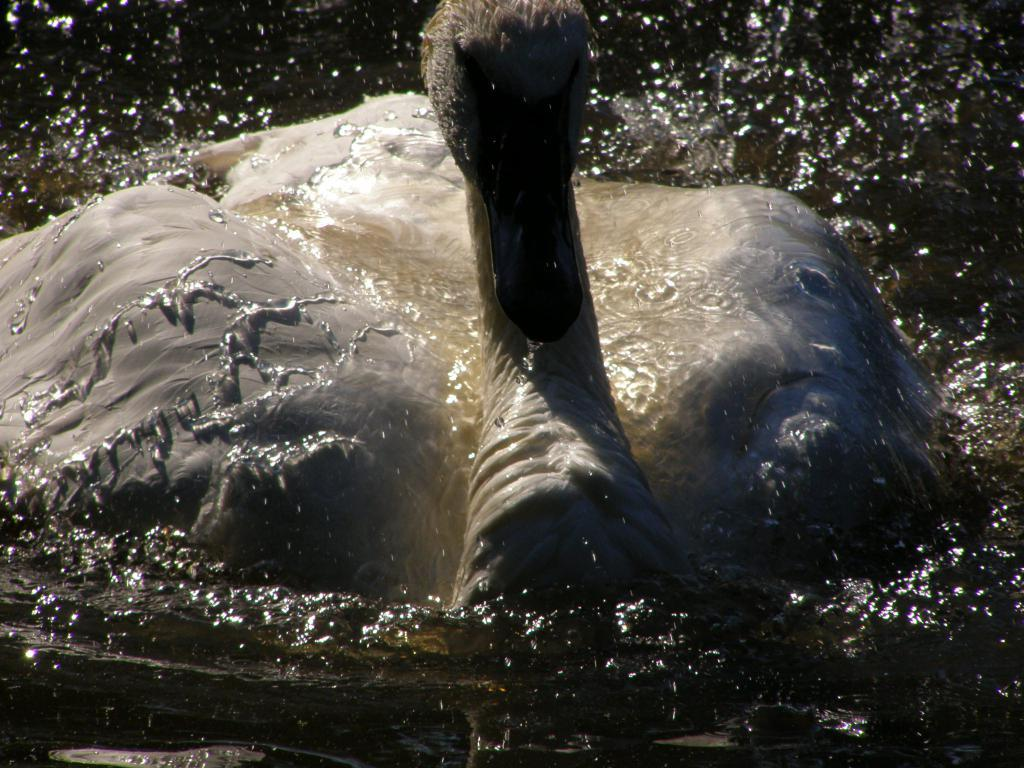What animal can be seen in the image? There is a swan in the image. What is the primary element in which the swan is situated? There is water visible in the image, and the swan is in it. What type of vegetable is being used to sew a potato in the image? There is no vegetable or potato present in the image; it features a swan in water. 